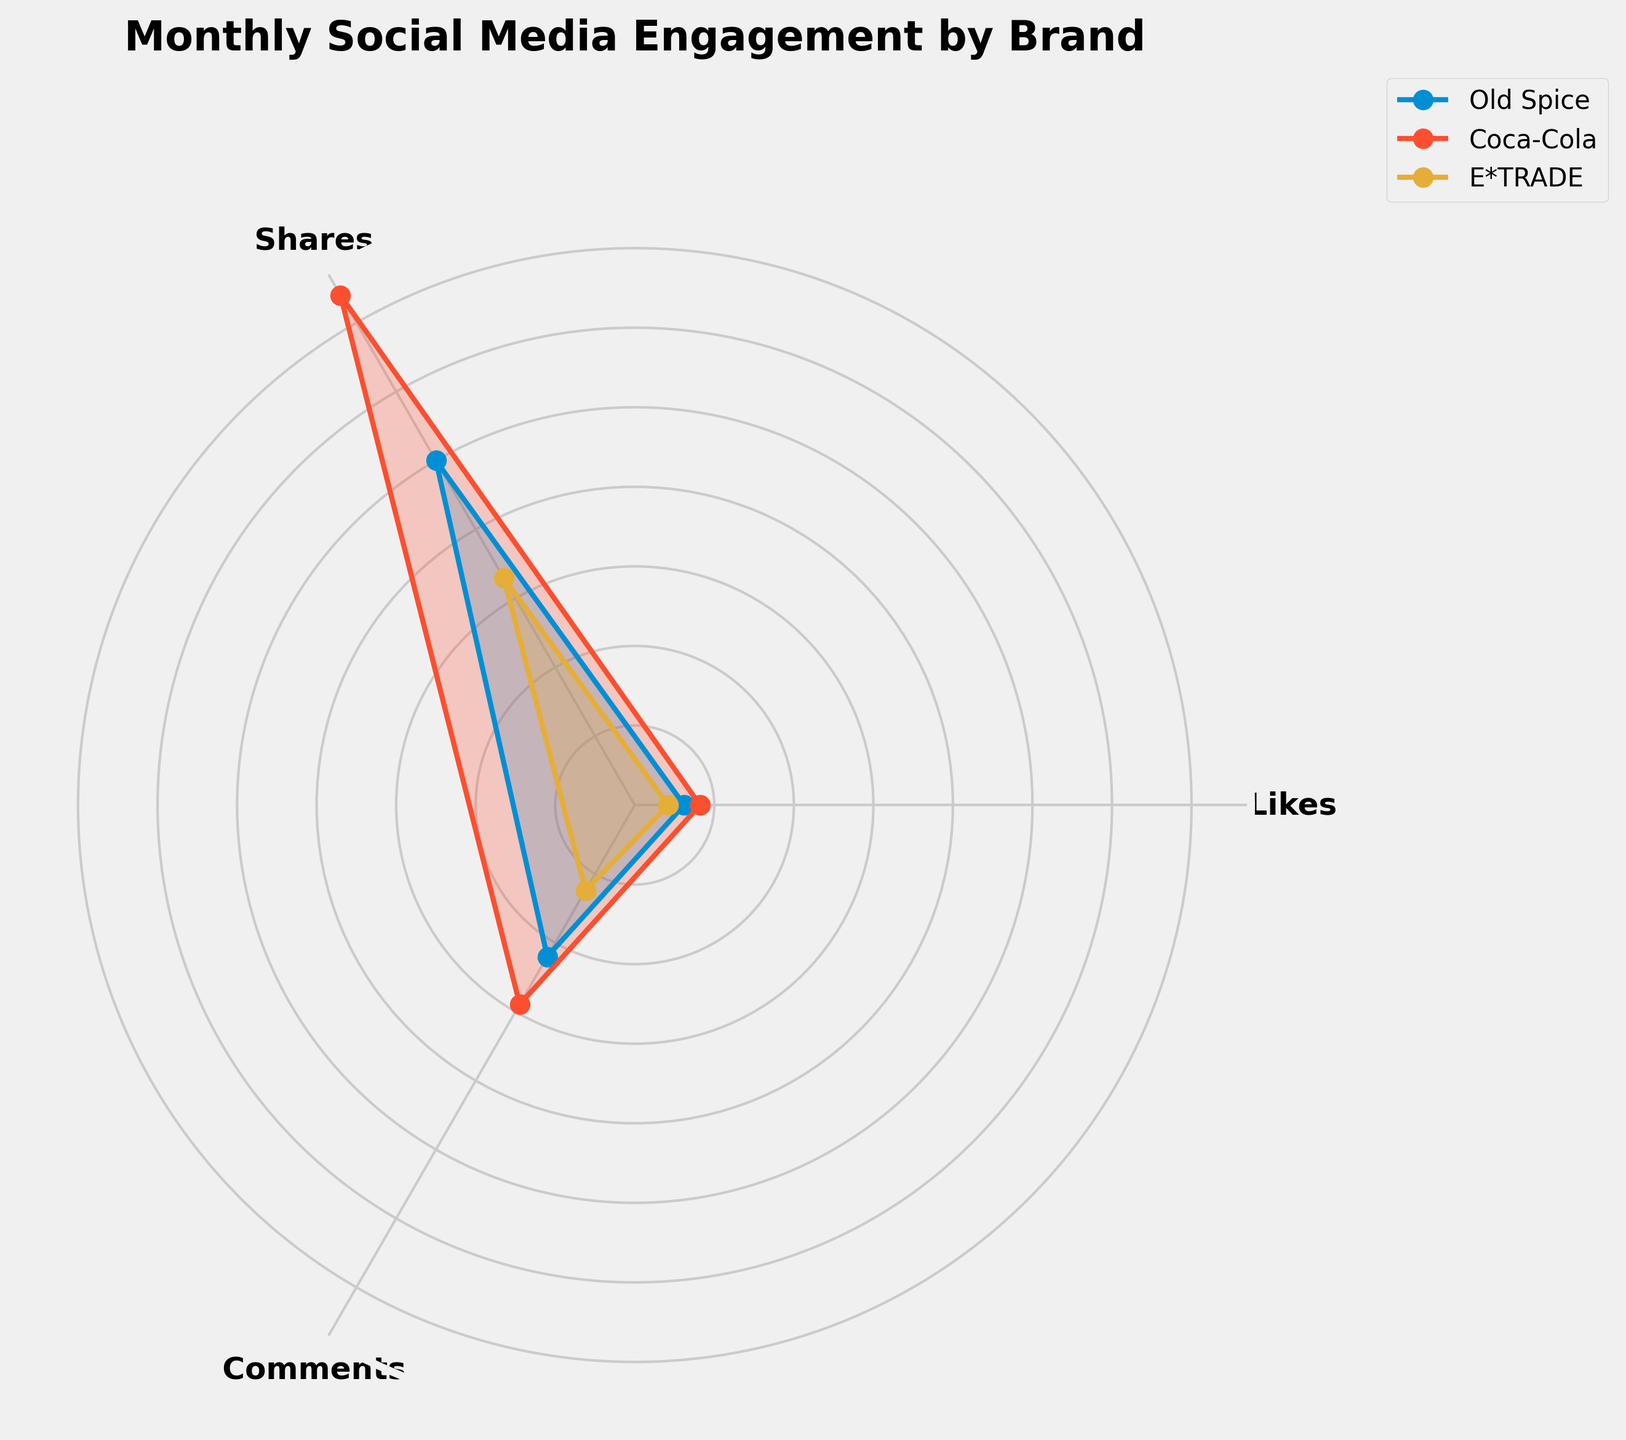How many groups are compared in the radar chart? The radar chart displays three distinct groups: Old Spice, Coca-Cola, and E*TRADE. By counting the number of differently colored sections and corresponding labels in the legend, we can identify these three groups.
Answer: 3 Which social media engagement metric does Coca-Cola perform best in, on average? By observing the radar chart, we notice that Coca-Cola consistently shows the highest values in 'Likes' among the three metrics (Likes, Shares, Comments) across the months. The 'Likes' segment will have the greatest radius for Coca-Cola.
Answer: Likes Between Old Spice and E*TRADE, which group had higher average shares? By comparing the radar chart sections for 'Shares' of Old Spice and E*TRADE, we observe that Old Spice had higher values in the 'Shares' category in each corresponding segment. This is evident from the larger radius of the 'Shares' metric for Old Spice.
Answer: Old Spice What is the overall trend in engagement metrics (Likes, Shares, Comments) for E*TRADE over the three months? The radar chart shows E*TRADE's engagement metrics with relatively consistent and lower values compared to Old Spice and Coca-Cola. It shows a slight increase in metrics like 'Likes' and 'Comments' from January to February, and a more steady pattern in March. Overall, the trend is fairly steady with minor increases.
Answer: Steady with minor increases If you consider only the 'Comments' metric, which group has the highest average value? By examining the sections of the radar chart for 'Comments,' we notice that Coca-Cola consistently has the highest values compared to Old Spice and E*TRADE. This is due to the larger radius of the 'Comments' sections for Coca-Cola across all months.
Answer: Coca-Cola In February, did Old Spice or Coca-Cola have more 'Shares'? By looking at the February data points for 'Shares' on the radar chart, we find that Coca-Cola's 'Shares' segment is larger and extends further outward than Old Spice's, indicating that Coca-Cola had more 'Shares' in February.
Answer: Coca-Cola Did any group show a decreasing trend in 'Likes' over the three months? By examining the 'Likes' segments for each group over January, February, and March on the radar chart, we see that Old Spice had a decrease from 13000 in February to 12500 in March. This indicates a decreasing trend for Old Spice.
Answer: Old Spice Which metric had the most similar values across all three groups? To determine the most similar values, observe the radar chart sectors for 'Comments' across Old Spice, Coca-Cola, and E*TRADE. They appear to be more closely aligned and with less variation compared to 'Likes' and 'Shares'. Therefore, the 'Comments' metric is the most similar across the groups.
Answer: Comments 